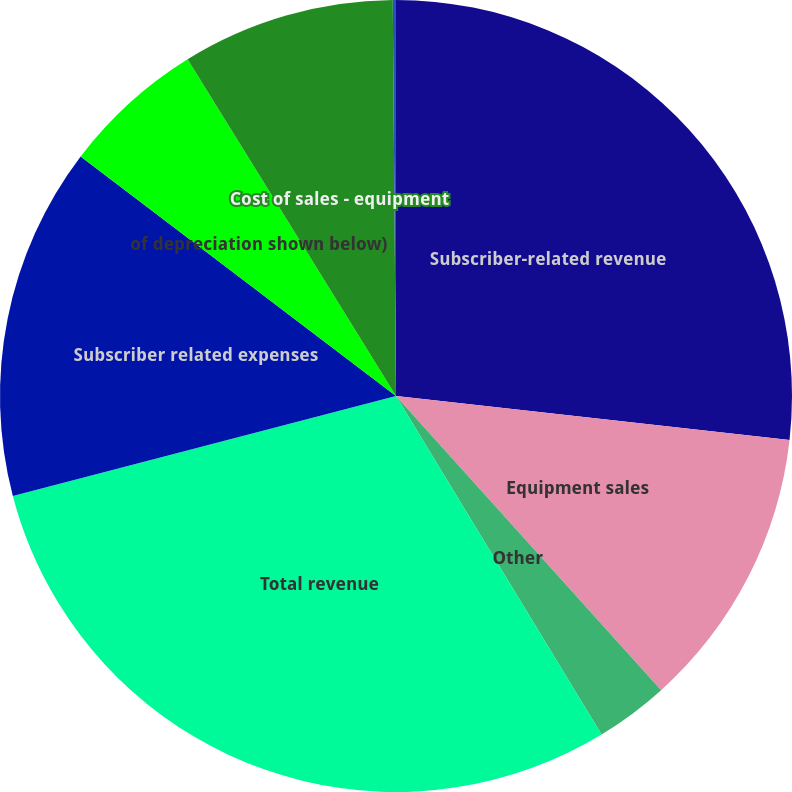<chart> <loc_0><loc_0><loc_500><loc_500><pie_chart><fcel>Subscriber-related revenue<fcel>Equipment sales<fcel>Other<fcel>Total revenue<fcel>Subscriber related expenses<fcel>of depreciation shown below)<fcel>Cost of sales - equipment<fcel>Cost of sales - other<nl><fcel>26.77%<fcel>11.55%<fcel>2.99%<fcel>29.62%<fcel>14.4%<fcel>5.84%<fcel>8.69%<fcel>0.13%<nl></chart> 